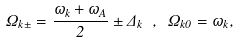<formula> <loc_0><loc_0><loc_500><loc_500>\Omega _ { { k } \pm } = \frac { \omega _ { k } + \omega _ { A } } { 2 } \pm \Delta _ { k } \ , \ \Omega _ { { k } 0 } = \omega _ { k } ,</formula> 